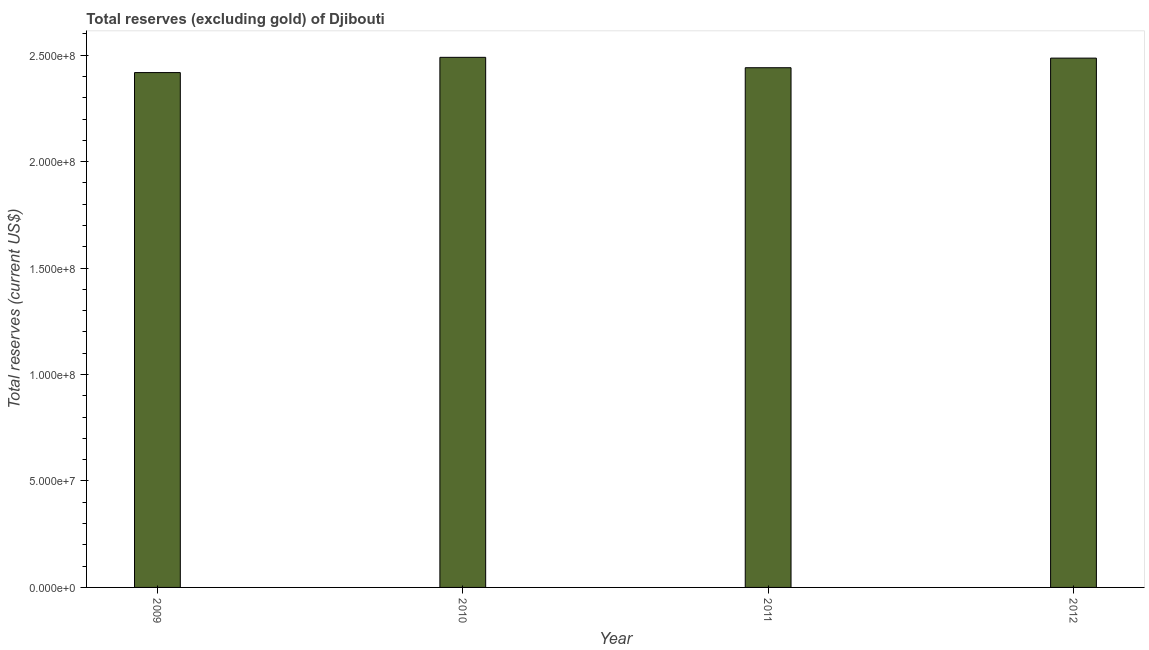Does the graph contain any zero values?
Your response must be concise. No. Does the graph contain grids?
Ensure brevity in your answer.  No. What is the title of the graph?
Your answer should be compact. Total reserves (excluding gold) of Djibouti. What is the label or title of the Y-axis?
Keep it short and to the point. Total reserves (current US$). What is the total reserves (excluding gold) in 2012?
Provide a succinct answer. 2.49e+08. Across all years, what is the maximum total reserves (excluding gold)?
Your answer should be very brief. 2.49e+08. Across all years, what is the minimum total reserves (excluding gold)?
Ensure brevity in your answer.  2.42e+08. In which year was the total reserves (excluding gold) maximum?
Provide a succinct answer. 2010. What is the sum of the total reserves (excluding gold)?
Offer a very short reply. 9.84e+08. What is the difference between the total reserves (excluding gold) in 2011 and 2012?
Provide a short and direct response. -4.52e+06. What is the average total reserves (excluding gold) per year?
Offer a terse response. 2.46e+08. What is the median total reserves (excluding gold)?
Keep it short and to the point. 2.46e+08. What is the ratio of the total reserves (excluding gold) in 2010 to that in 2011?
Offer a very short reply. 1.02. Is the difference between the total reserves (excluding gold) in 2009 and 2012 greater than the difference between any two years?
Keep it short and to the point. No. What is the difference between the highest and the second highest total reserves (excluding gold)?
Your answer should be compact. 3.68e+05. What is the difference between the highest and the lowest total reserves (excluding gold)?
Your answer should be compact. 7.17e+06. Are all the bars in the graph horizontal?
Offer a terse response. No. How many years are there in the graph?
Offer a very short reply. 4. Are the values on the major ticks of Y-axis written in scientific E-notation?
Give a very brief answer. Yes. What is the Total reserves (current US$) in 2009?
Offer a very short reply. 2.42e+08. What is the Total reserves (current US$) of 2010?
Provide a short and direct response. 2.49e+08. What is the Total reserves (current US$) of 2011?
Your response must be concise. 2.44e+08. What is the Total reserves (current US$) of 2012?
Offer a terse response. 2.49e+08. What is the difference between the Total reserves (current US$) in 2009 and 2010?
Your answer should be very brief. -7.17e+06. What is the difference between the Total reserves (current US$) in 2009 and 2011?
Give a very brief answer. -2.28e+06. What is the difference between the Total reserves (current US$) in 2009 and 2012?
Ensure brevity in your answer.  -6.80e+06. What is the difference between the Total reserves (current US$) in 2010 and 2011?
Keep it short and to the point. 4.89e+06. What is the difference between the Total reserves (current US$) in 2010 and 2012?
Keep it short and to the point. 3.68e+05. What is the difference between the Total reserves (current US$) in 2011 and 2012?
Give a very brief answer. -4.52e+06. What is the ratio of the Total reserves (current US$) in 2009 to that in 2010?
Your answer should be compact. 0.97. What is the ratio of the Total reserves (current US$) in 2010 to that in 2011?
Provide a succinct answer. 1.02. What is the ratio of the Total reserves (current US$) in 2010 to that in 2012?
Give a very brief answer. 1. What is the ratio of the Total reserves (current US$) in 2011 to that in 2012?
Keep it short and to the point. 0.98. 